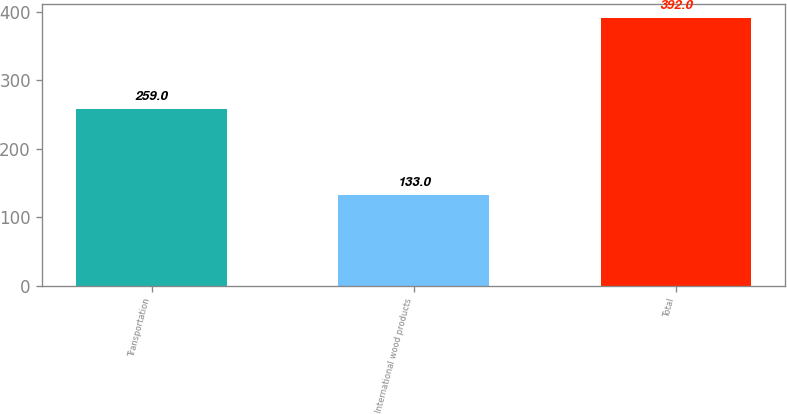Convert chart. <chart><loc_0><loc_0><loc_500><loc_500><bar_chart><fcel>Transportation<fcel>International wood products<fcel>Total<nl><fcel>259<fcel>133<fcel>392<nl></chart> 